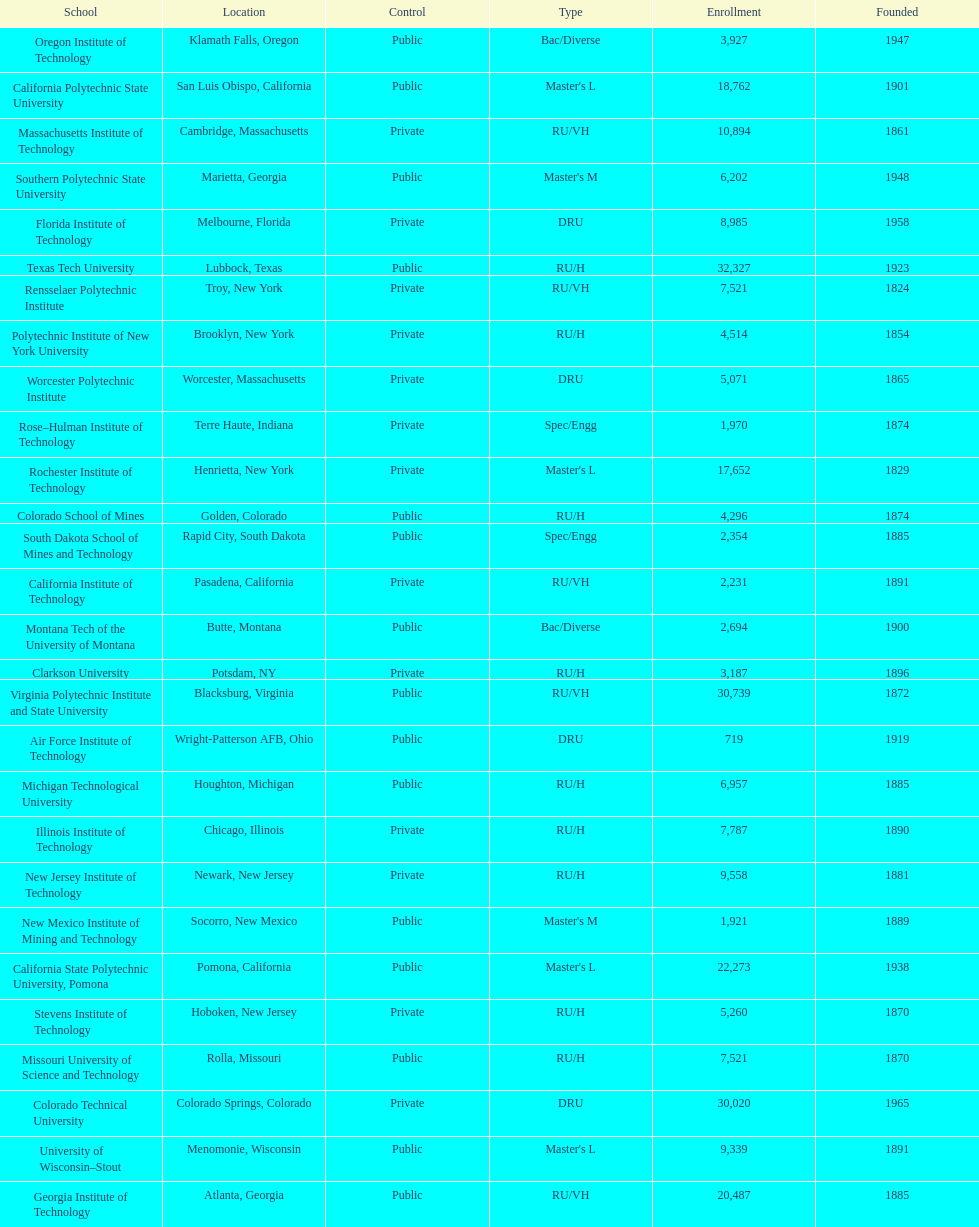What is the number of us technological schools in the state of california? 3. 